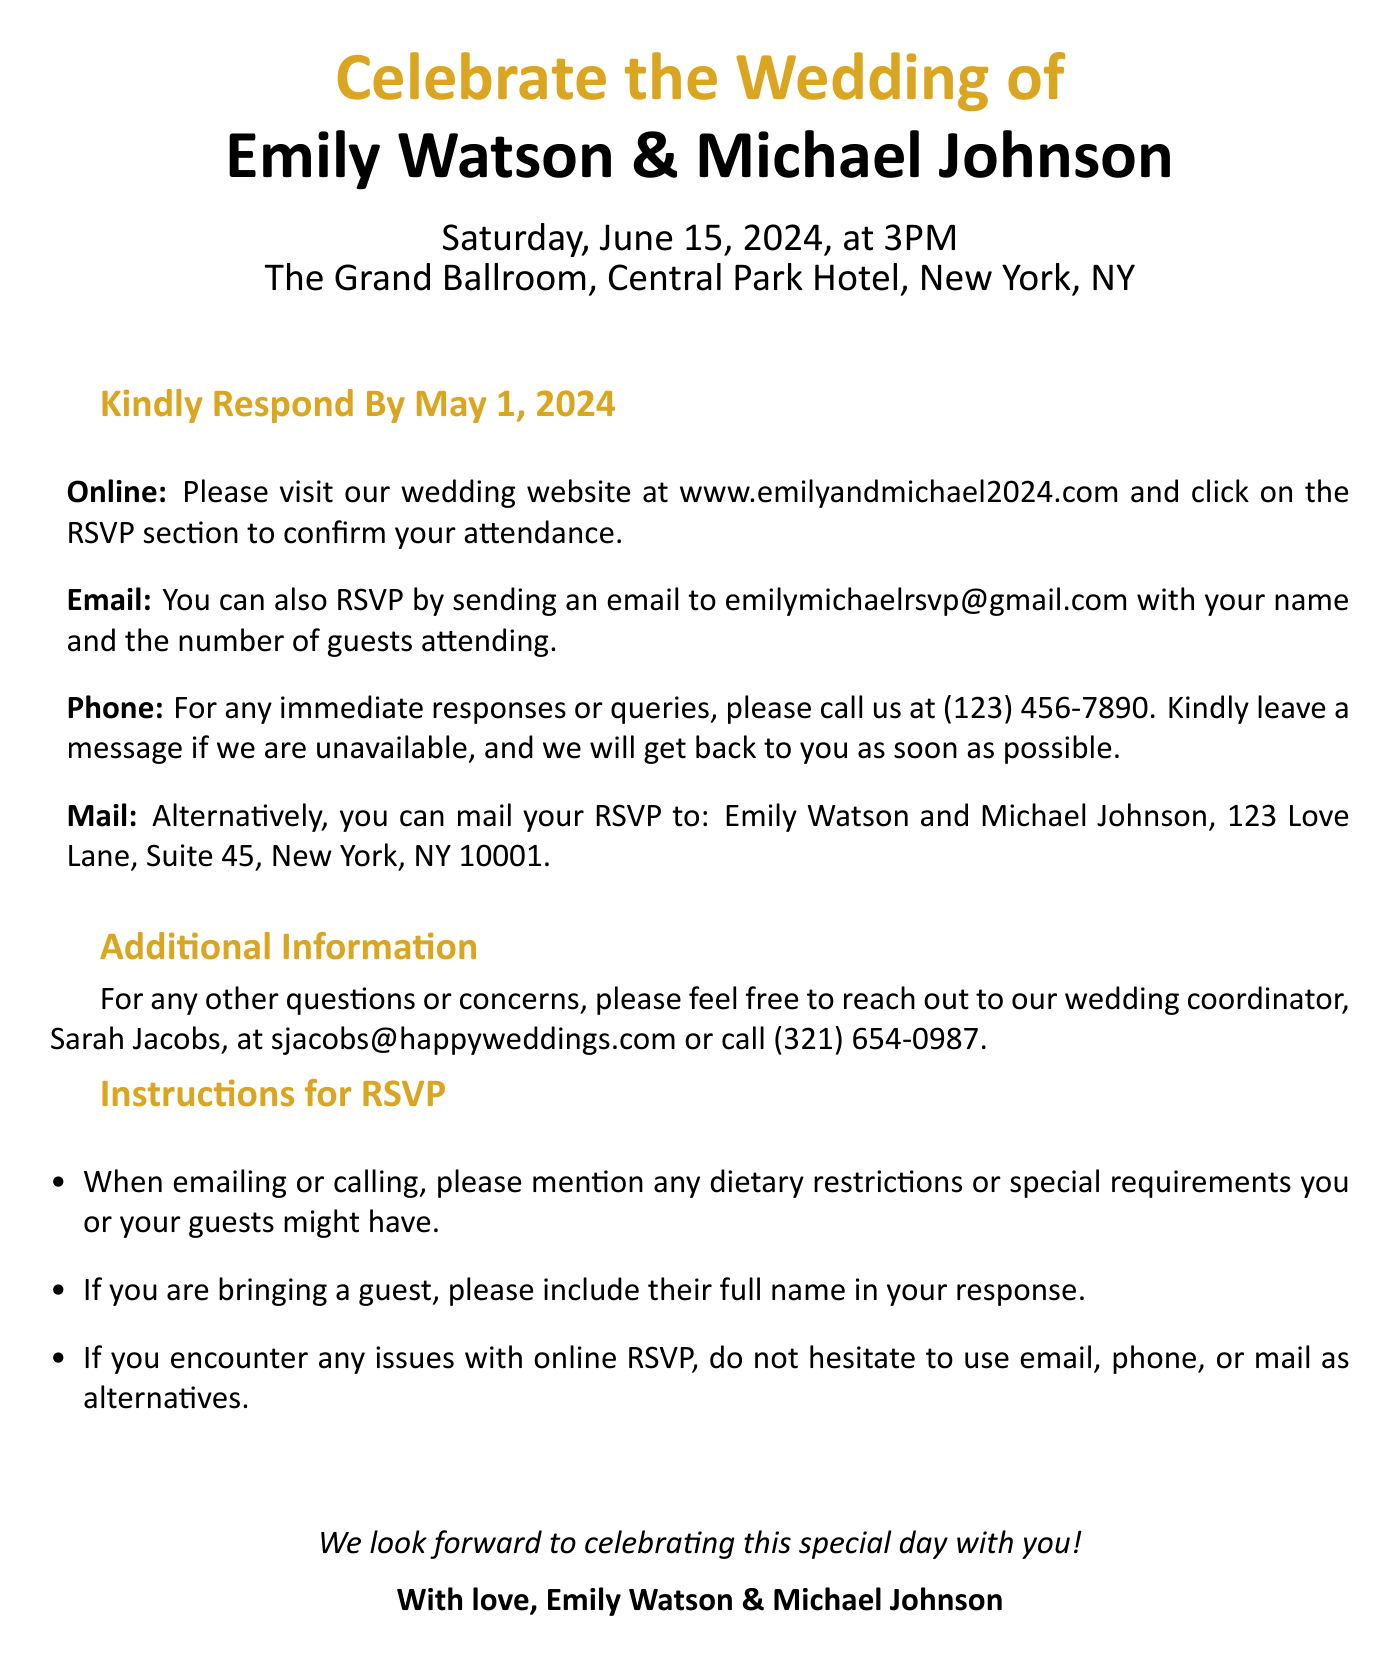What is the date of the wedding? The date of the wedding is explicitly stated in the document as June 15, 2024.
Answer: June 15, 2024 What time does the wedding ceremony begin? The document specifies that the wedding ceremony begins at 3PM.
Answer: 3PM What is the venue for the wedding? The venue is mentioned as The Grand Ballroom, Central Park Hotel, New York, NY in the document.
Answer: The Grand Ballroom, Central Park Hotel, New York, NY What is the RSVP deadline? The deadline for RSVPs is clearly stated as May 1, 2024.
Answer: May 1, 2024 How can guests respond online? The document describes that guests can visit the wedding website and click on the RSVP section to confirm attendance online.
Answer: Wedding website What is the email address for RSVPs? The email address provided for RSVPs in the document is emilymichaelrsvp@gmail.com.
Answer: emilymichaelrsvp@gmail.com Who should guests contact for other questions? Guests can reach out to Sarah Jacobs for other questions, as indicated in the document.
Answer: Sarah Jacobs How should guests indicate dietary restrictions? Guests are instructed to mention any dietary restrictions when emailing or calling for their RSVP.
Answer: Emailing or calling What is the mailing address for RSVPs? The RSVP mailing address given in the document is 123 Love Lane, Suite 45, New York, NY 10001.
Answer: 123 Love Lane, Suite 45, New York, NY 10001 